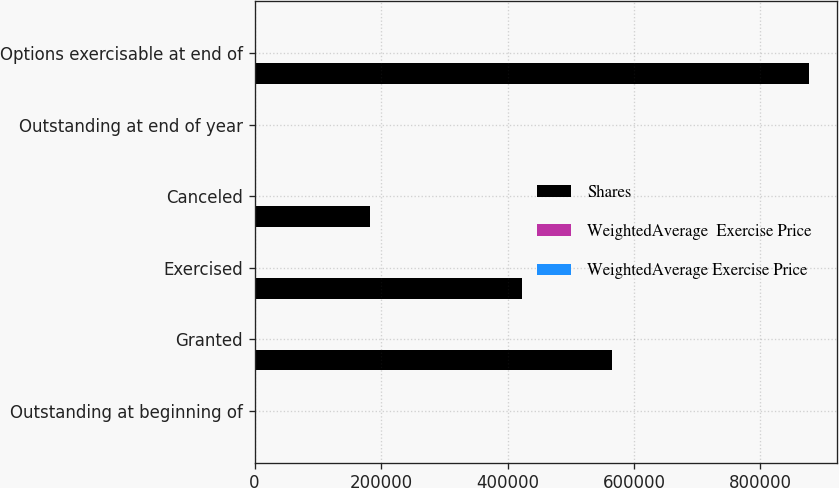Convert chart. <chart><loc_0><loc_0><loc_500><loc_500><stacked_bar_chart><ecel><fcel>Outstanding at beginning of<fcel>Granted<fcel>Exercised<fcel>Canceled<fcel>Outstanding at end of year<fcel>Options exercisable at end of<nl><fcel>Shares<fcel>26.195<fcel>565200<fcel>422586<fcel>182837<fcel>26.195<fcel>877068<nl><fcel>WeightedAverage  Exercise Price<fcel>25.37<fcel>48.62<fcel>20.26<fcel>29.85<fcel>31.04<fcel>23.11<nl><fcel>WeightedAverage Exercise Price<fcel>19.34<fcel>27.02<fcel>17.2<fcel>21.92<fcel>21.61<fcel>17.64<nl></chart> 